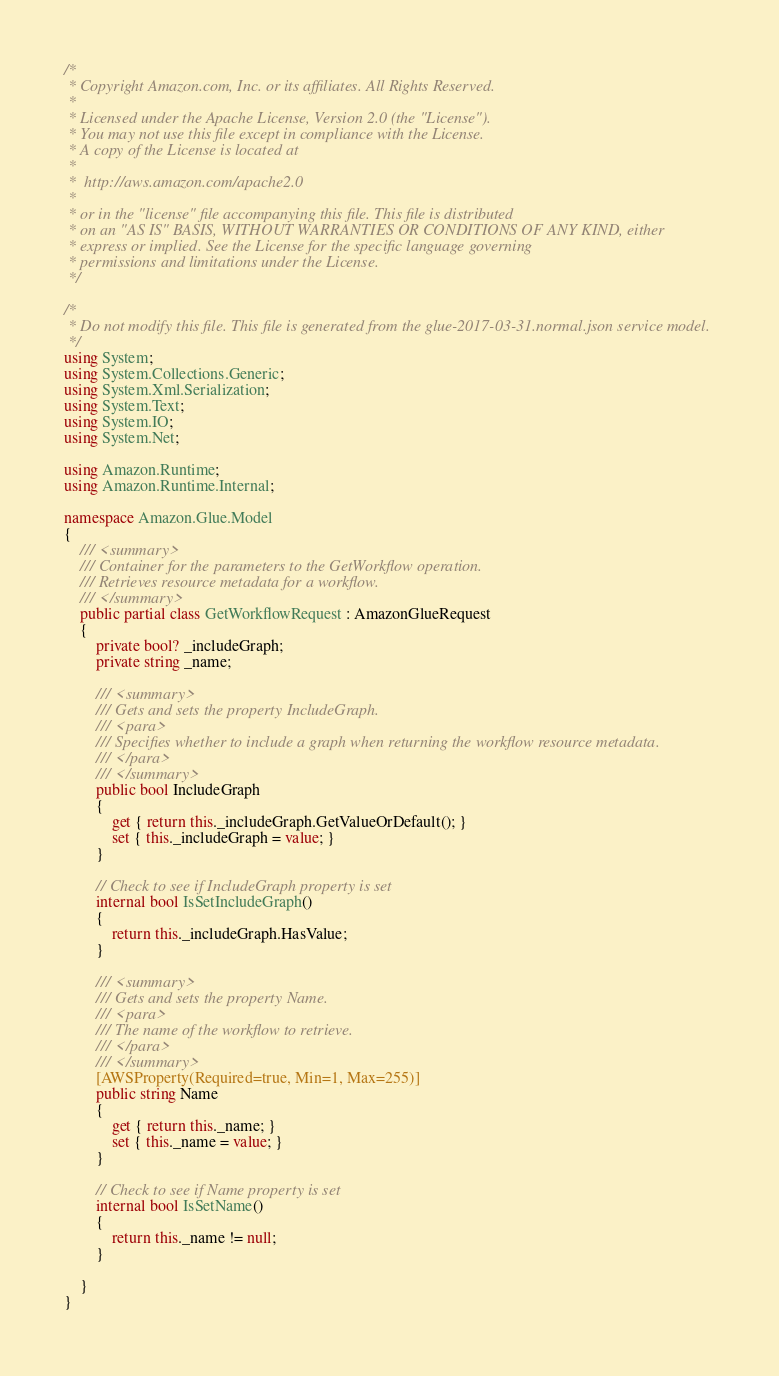<code> <loc_0><loc_0><loc_500><loc_500><_C#_>/*
 * Copyright Amazon.com, Inc. or its affiliates. All Rights Reserved.
 * 
 * Licensed under the Apache License, Version 2.0 (the "License").
 * You may not use this file except in compliance with the License.
 * A copy of the License is located at
 * 
 *  http://aws.amazon.com/apache2.0
 * 
 * or in the "license" file accompanying this file. This file is distributed
 * on an "AS IS" BASIS, WITHOUT WARRANTIES OR CONDITIONS OF ANY KIND, either
 * express or implied. See the License for the specific language governing
 * permissions and limitations under the License.
 */

/*
 * Do not modify this file. This file is generated from the glue-2017-03-31.normal.json service model.
 */
using System;
using System.Collections.Generic;
using System.Xml.Serialization;
using System.Text;
using System.IO;
using System.Net;

using Amazon.Runtime;
using Amazon.Runtime.Internal;

namespace Amazon.Glue.Model
{
    /// <summary>
    /// Container for the parameters to the GetWorkflow operation.
    /// Retrieves resource metadata for a workflow.
    /// </summary>
    public partial class GetWorkflowRequest : AmazonGlueRequest
    {
        private bool? _includeGraph;
        private string _name;

        /// <summary>
        /// Gets and sets the property IncludeGraph. 
        /// <para>
        /// Specifies whether to include a graph when returning the workflow resource metadata.
        /// </para>
        /// </summary>
        public bool IncludeGraph
        {
            get { return this._includeGraph.GetValueOrDefault(); }
            set { this._includeGraph = value; }
        }

        // Check to see if IncludeGraph property is set
        internal bool IsSetIncludeGraph()
        {
            return this._includeGraph.HasValue; 
        }

        /// <summary>
        /// Gets and sets the property Name. 
        /// <para>
        /// The name of the workflow to retrieve.
        /// </para>
        /// </summary>
        [AWSProperty(Required=true, Min=1, Max=255)]
        public string Name
        {
            get { return this._name; }
            set { this._name = value; }
        }

        // Check to see if Name property is set
        internal bool IsSetName()
        {
            return this._name != null;
        }

    }
}</code> 